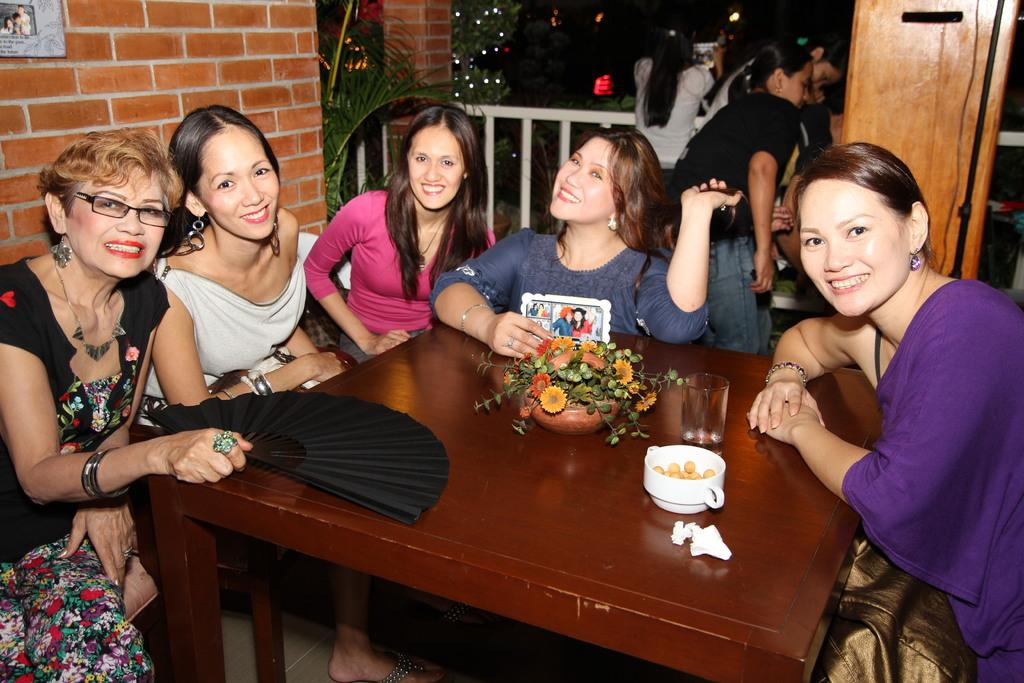What object can be seen on the table in the image? There is a flower on the table. What else is on the table besides the flower? There is a glass and a bowl on the table. Who is present around the table in the image? Women are sitting around the table. What can be seen in the background of the image? There is a wall and trees in the background. What type of produce is being used to create the quilt in the image? There is no quilt or produce present in the image. What arithmetic problem are the women solving together in the image? There is no indication of any arithmetic problem being solved in the image. 